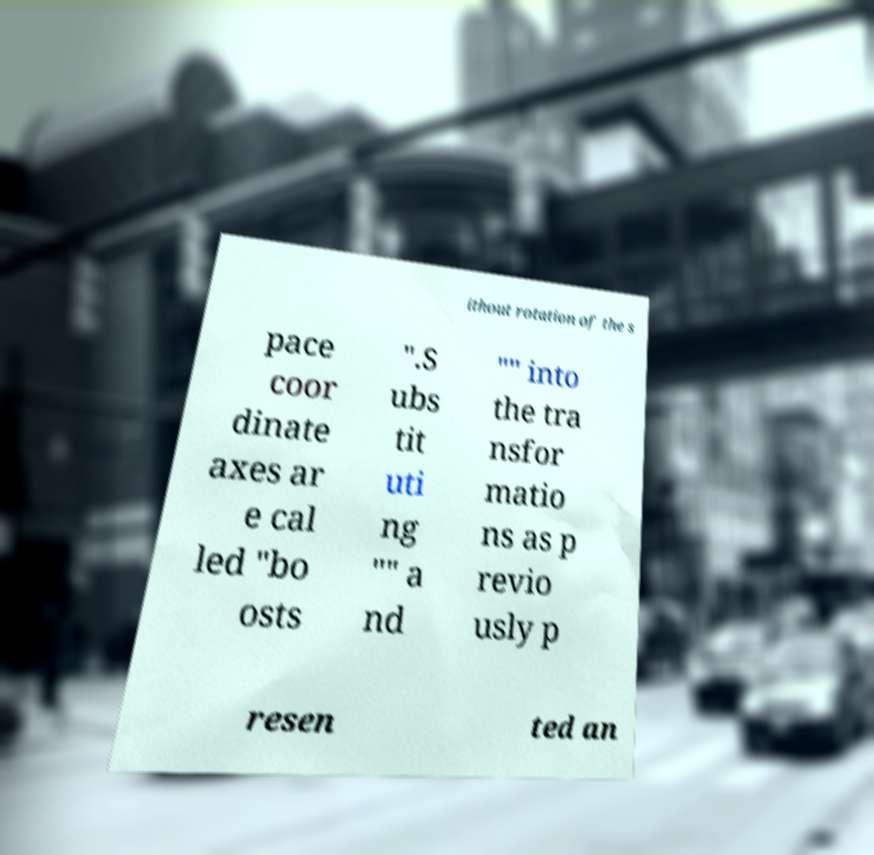Could you extract and type out the text from this image? ithout rotation of the s pace coor dinate axes ar e cal led "bo osts ".S ubs tit uti ng "" a nd "" into the tra nsfor matio ns as p revio usly p resen ted an 